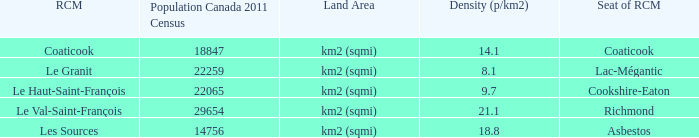What is the seat of the county that has a density of 14.1? Coaticook. 